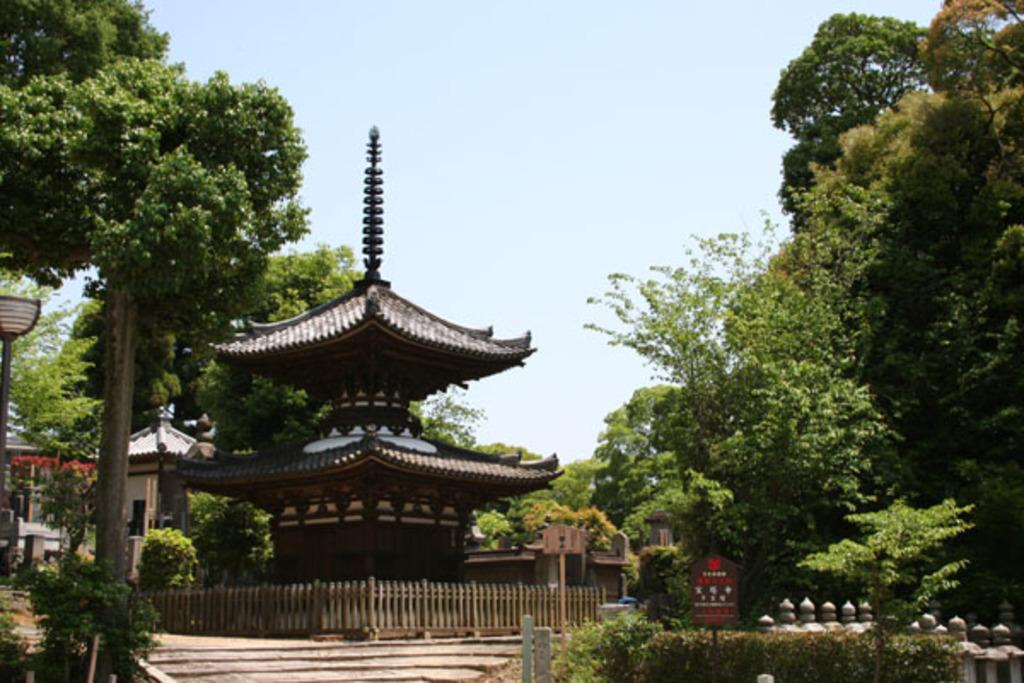What is located in the center of the image? There are buildings in the center of the image. What type of natural elements can be seen in the image? There are trees in the image. What type of barrier is present in the image? There is a fence in the image. What type of vertical structures are present in the image? There are poles in the image. What type of flat, rectangular objects are present in the image? There are boards in the image. What type of vegetation is at the bottom of the image? There are plants at the bottom of the image. What is visible at the top of the image? The sky is visible at the top of the image. How many apples are hanging from the trees in the image? There are no apples present in the image; only trees are visible. What type of sporting equipment is being used in the image? There is no sporting equipment present in the image. 